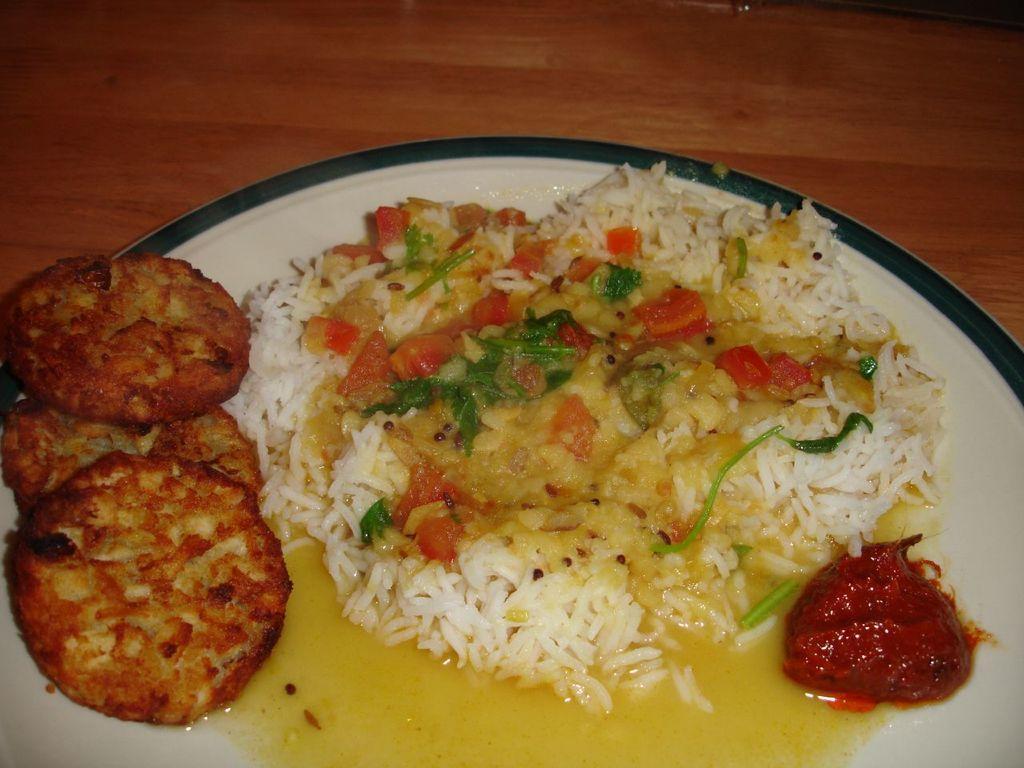Describe this image in one or two sentences. It is the rice with curries, chutney in a white color plate. 